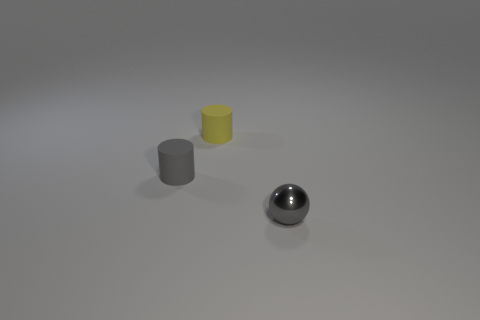There is a gray thing behind the small ball; is there a gray object in front of it?
Your answer should be very brief. Yes. Is there a tiny red matte cube?
Provide a succinct answer. No. What color is the thing in front of the matte cylinder in front of the yellow thing?
Provide a succinct answer. Gray. What material is the small gray thing that is the same shape as the small yellow thing?
Your answer should be compact. Rubber. How many brown matte cylinders are the same size as the gray ball?
Give a very brief answer. 0. The gray cylinder that is the same material as the yellow thing is what size?
Keep it short and to the point. Small. What number of other small rubber objects have the same shape as the small yellow rubber thing?
Your response must be concise. 1. What number of gray matte things are there?
Give a very brief answer. 1. Do the thing that is left of the tiny yellow rubber object and the small yellow object have the same shape?
Make the answer very short. Yes. What material is the ball that is the same size as the yellow matte cylinder?
Your answer should be compact. Metal. 